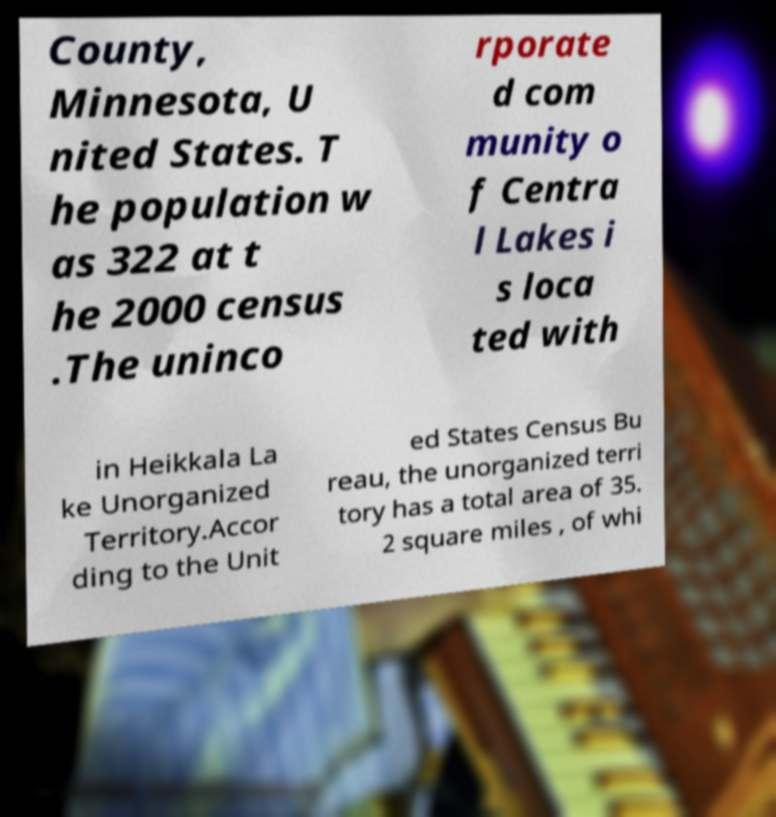Could you extract and type out the text from this image? County, Minnesota, U nited States. T he population w as 322 at t he 2000 census .The uninco rporate d com munity o f Centra l Lakes i s loca ted with in Heikkala La ke Unorganized Territory.Accor ding to the Unit ed States Census Bu reau, the unorganized terri tory has a total area of 35. 2 square miles , of whi 